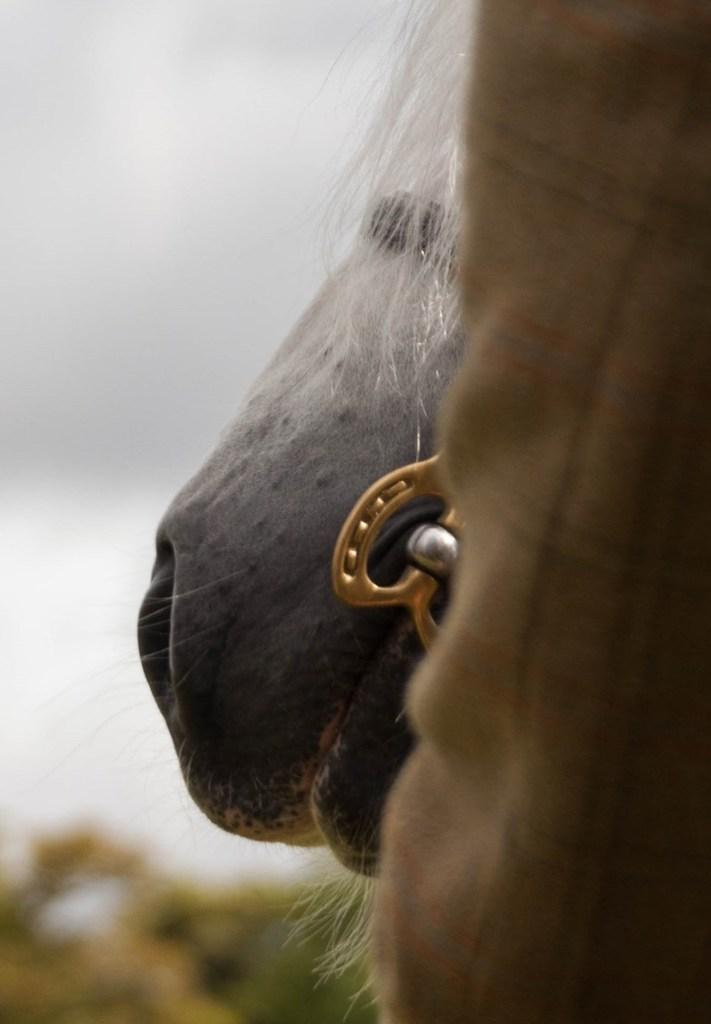What type of animal is in the image? The type of animal cannot be determined from the provided facts. What else is present in the image besides the animal? There is a cloth in the image. Can you describe the background of the image? The background of the image is blurred. What type of stick can be seen in the image? There is no stick present in the image. What is the animal eating for lunch in the image? There is no indication of the animal eating lunch in the image, as the type of animal and its actions are not specified. 